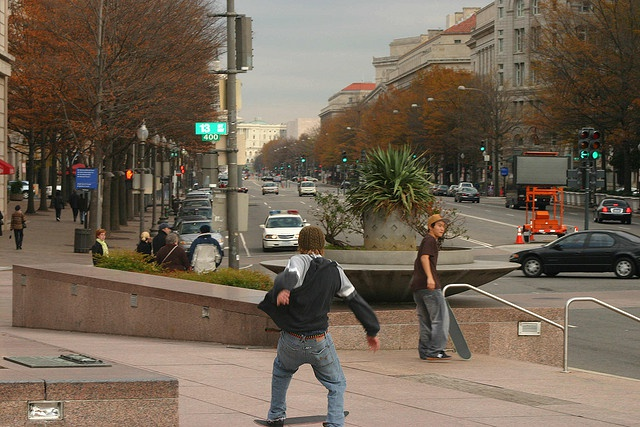Describe the objects in this image and their specific colors. I can see people in tan, black, gray, darkgray, and maroon tones, potted plant in tan, black, darkgreen, gray, and maroon tones, car in tan, black, gray, darkgray, and purple tones, people in tan, black, gray, and maroon tones, and potted plant in tan, gray, darkgreen, and black tones in this image. 